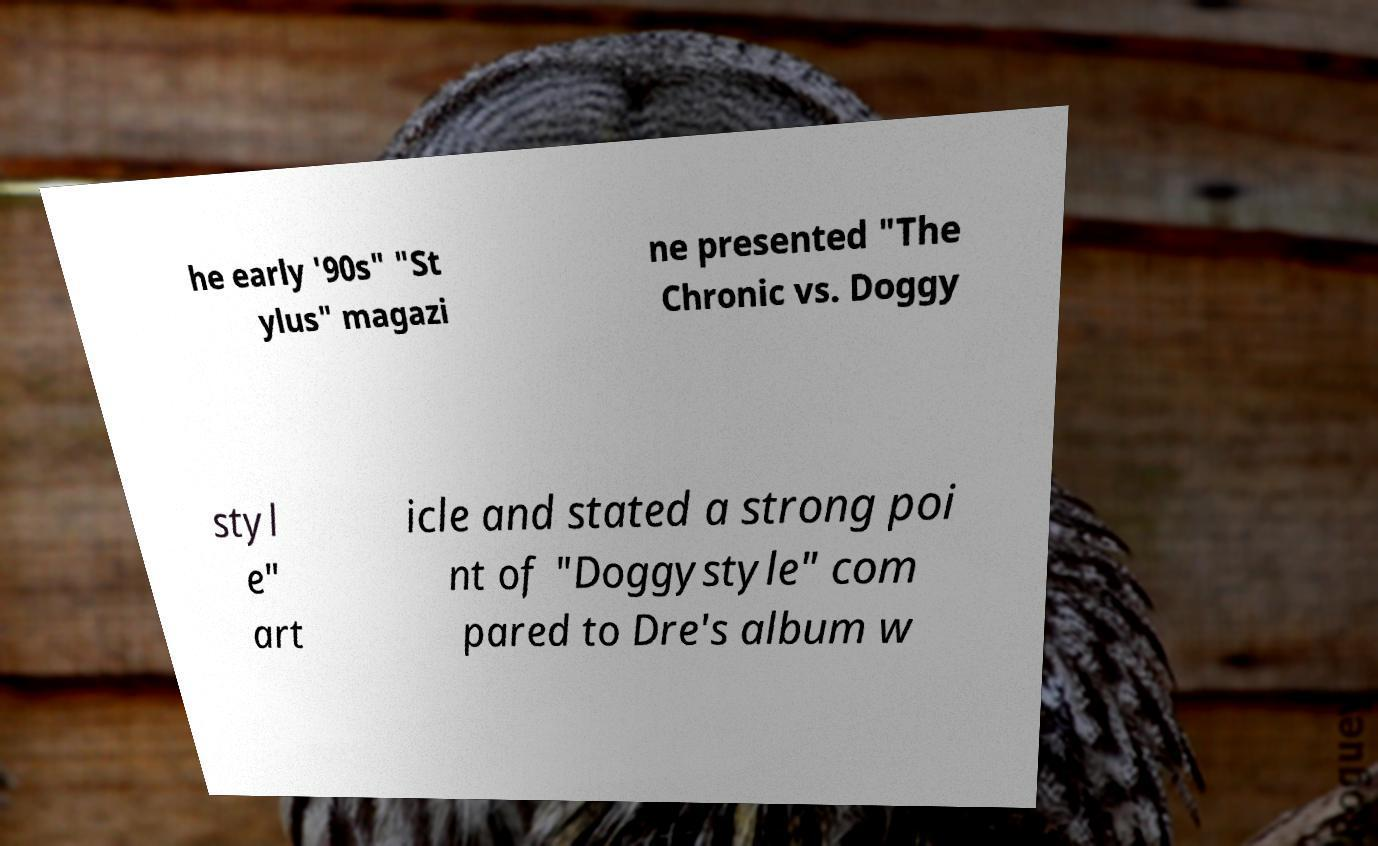What messages or text are displayed in this image? I need them in a readable, typed format. he early '90s" "St ylus" magazi ne presented "The Chronic vs. Doggy styl e" art icle and stated a strong poi nt of "Doggystyle" com pared to Dre's album w 